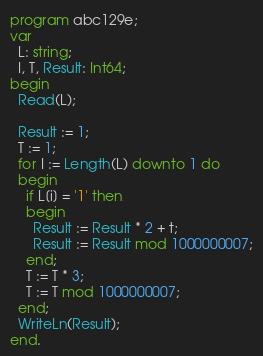<code> <loc_0><loc_0><loc_500><loc_500><_Pascal_>program abc129e;
var
  L: string;
  I, T, Result: Int64;
begin
  Read(L);

  Result := 1;
  T := 1;
  for I := Length(L) downto 1 do
  begin
    if L[i] = '1' then
    begin
      Result := Result * 2 + t;
      Result := Result mod 1000000007;
    end;
    T := T * 3;
    T := T mod 1000000007;
  end;
  WriteLn(Result);
end.</code> 